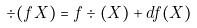<formula> <loc_0><loc_0><loc_500><loc_500>\div ( f X ) = f \div ( X ) + d f ( X )</formula> 